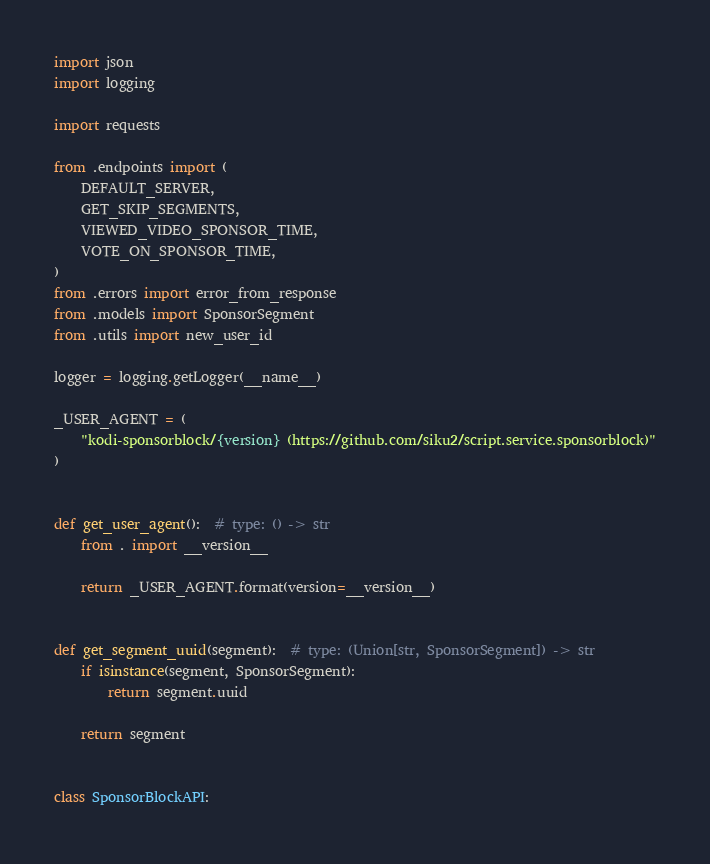Convert code to text. <code><loc_0><loc_0><loc_500><loc_500><_Python_>import json
import logging

import requests

from .endpoints import (
    DEFAULT_SERVER,
    GET_SKIP_SEGMENTS,
    VIEWED_VIDEO_SPONSOR_TIME,
    VOTE_ON_SPONSOR_TIME,
)
from .errors import error_from_response
from .models import SponsorSegment
from .utils import new_user_id

logger = logging.getLogger(__name__)

_USER_AGENT = (
    "kodi-sponsorblock/{version} (https://github.com/siku2/script.service.sponsorblock)"
)


def get_user_agent():  # type: () -> str
    from . import __version__

    return _USER_AGENT.format(version=__version__)


def get_segment_uuid(segment):  # type: (Union[str, SponsorSegment]) -> str
    if isinstance(segment, SponsorSegment):
        return segment.uuid

    return segment


class SponsorBlockAPI:</code> 